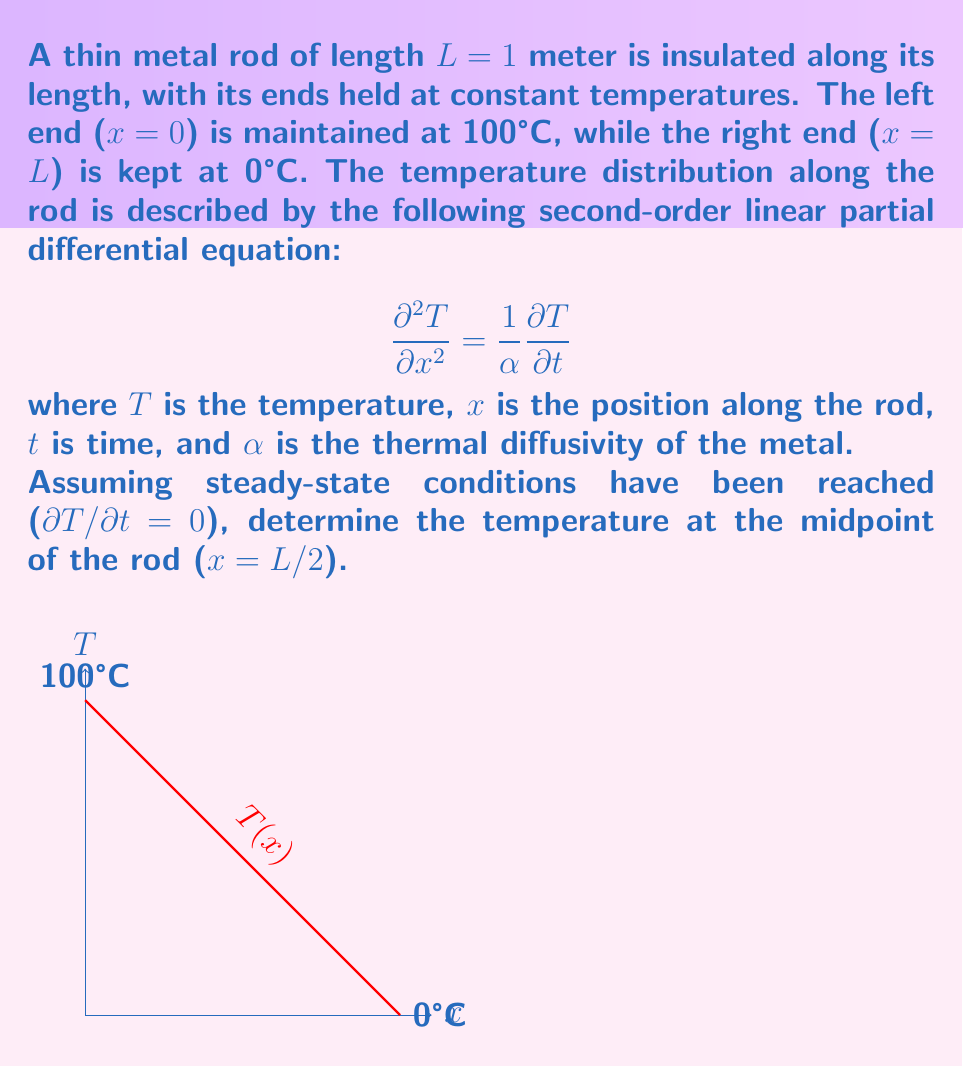Help me with this question. Let's solve this problem step by step:

1) Under steady-state conditions, ∂T/∂t = 0, so our equation reduces to:

   $$\frac{d^2T}{dx^2} = 0$$

2) The general solution to this equation is:

   $$T(x) = Ax + B$$

   where A and B are constants to be determined from the boundary conditions.

3) We have the following boundary conditions:
   - At x = 0, T = 100°C
   - At x = L = 1m, T = 0°C

4) Applying these conditions:
   - At x = 0: 100 = A(0) + B, so B = 100
   - At x = 1: 0 = A(1) + 100, so A = -100

5) Therefore, our temperature distribution is:

   $$T(x) = -100x + 100$$

6) To find the temperature at the midpoint (x = L/2 = 0.5m), we substitute x = 0.5 into our equation:

   $$T(0.5) = -100(0.5) + 100 = -50 + 100 = 50$$

Thus, the temperature at the midpoint of the rod is 50°C.
Answer: 50°C 